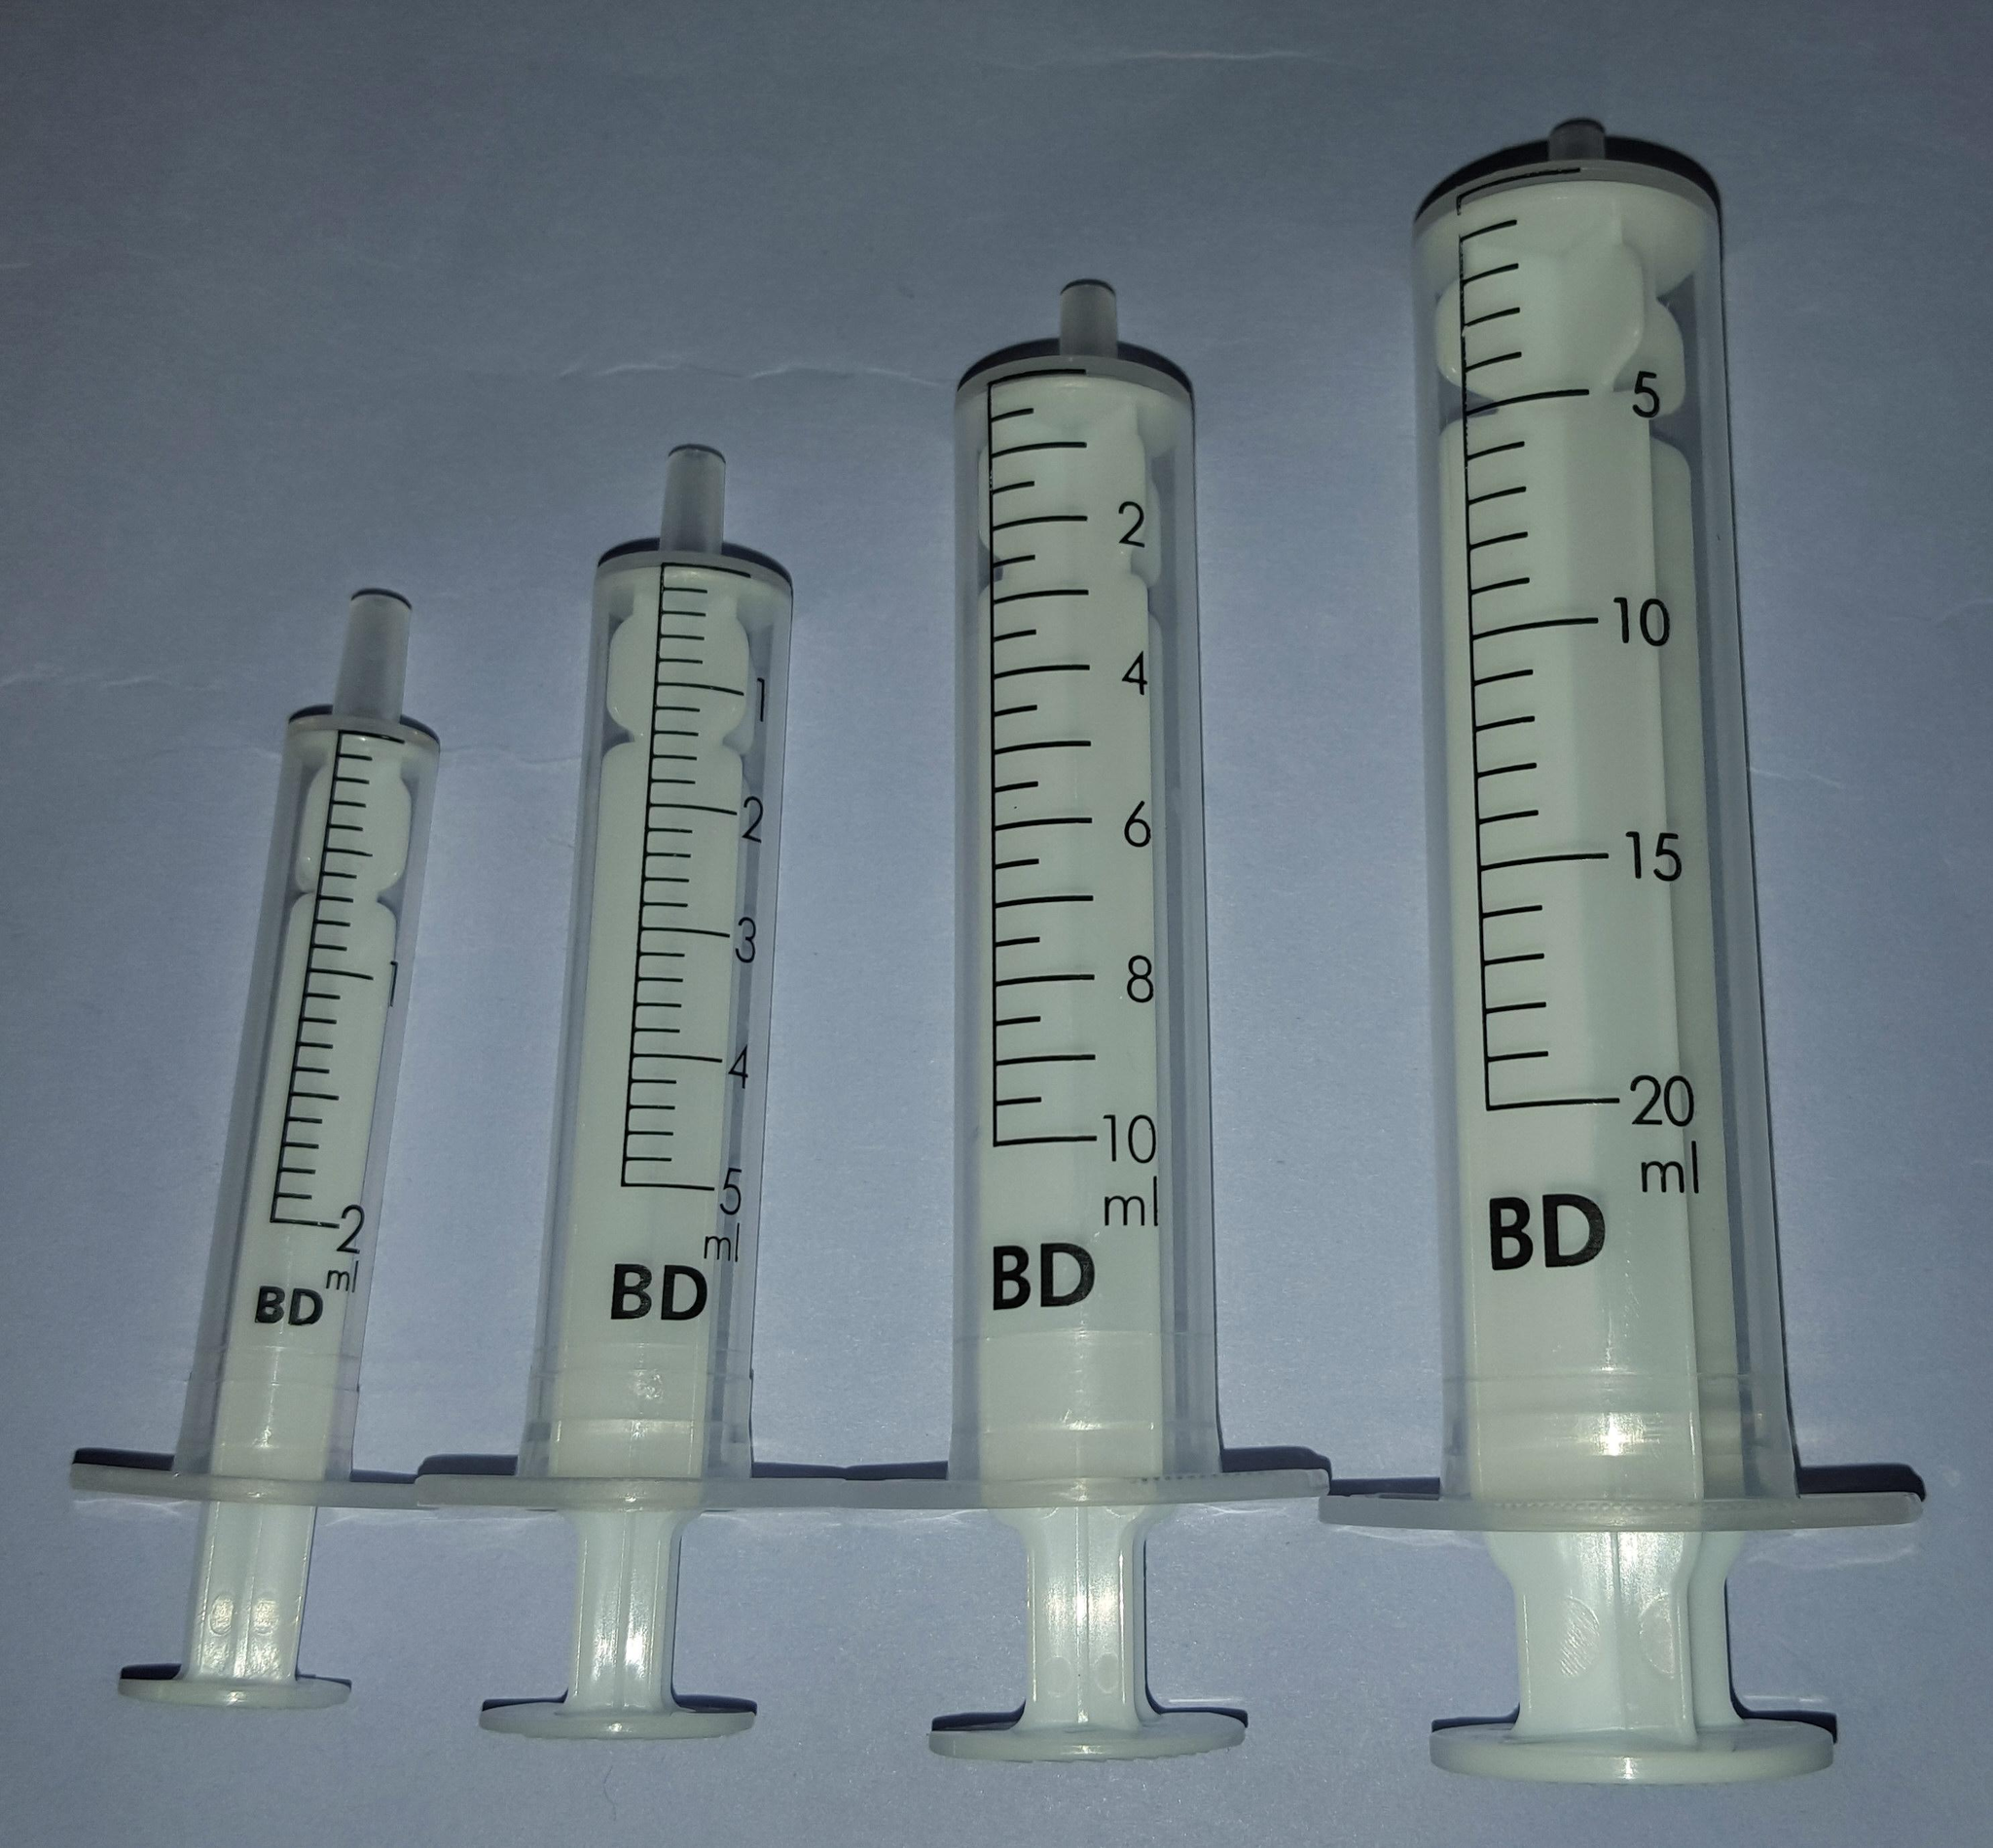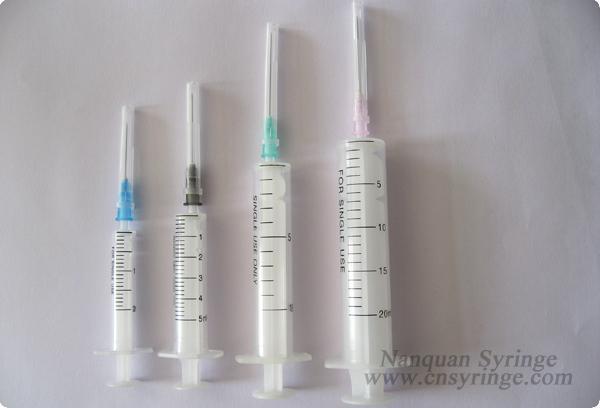The first image is the image on the left, the second image is the image on the right. Assess this claim about the two images: "There are eight syringes in total.". Correct or not? Answer yes or no. Yes. The first image is the image on the left, the second image is the image on the right. Assess this claim about the two images: "At least one image shows a horizontal row of syringes arranged in order of size.". Correct or not? Answer yes or no. Yes. 